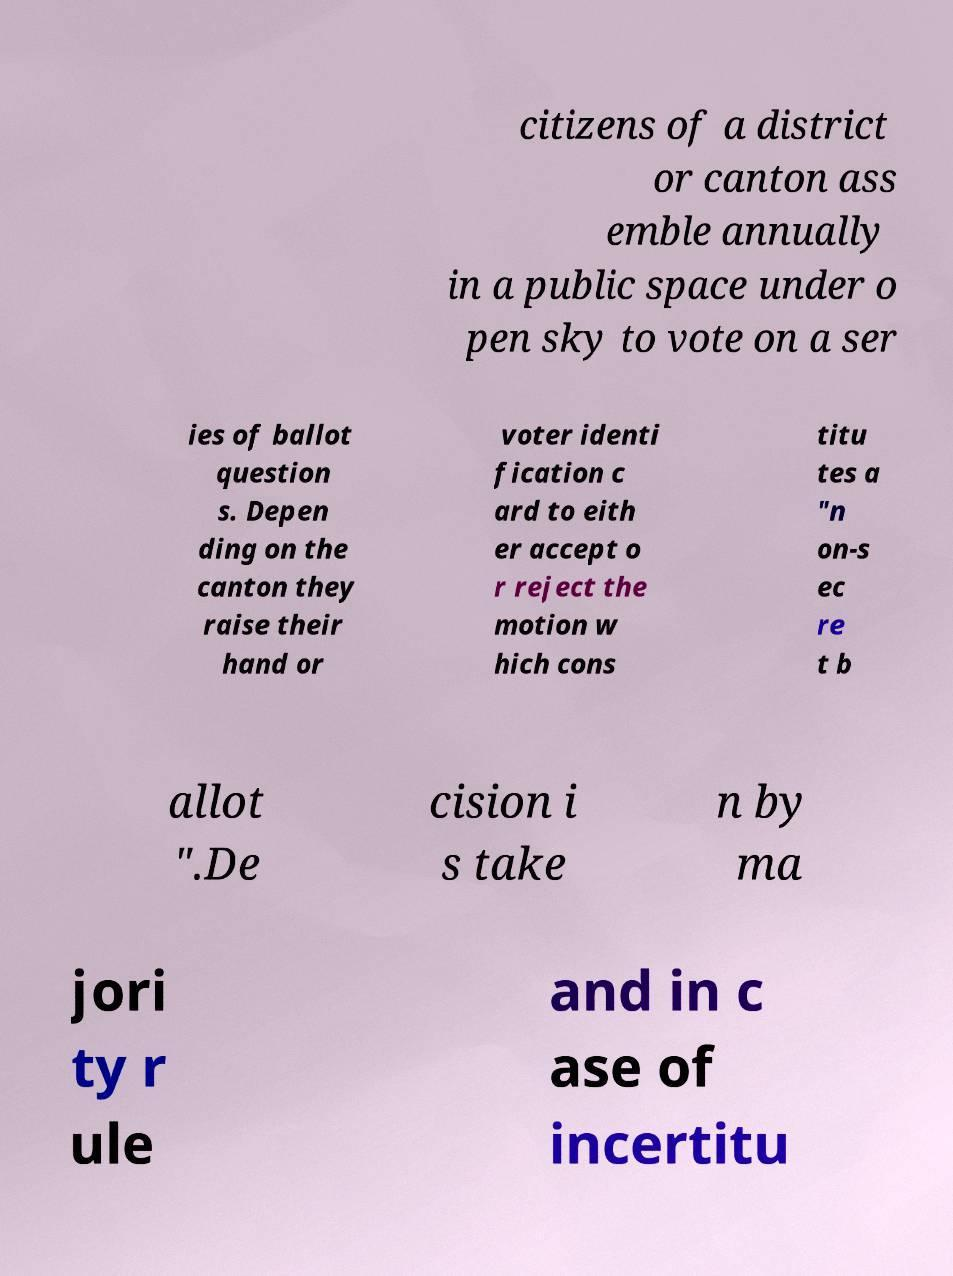Please identify and transcribe the text found in this image. citizens of a district or canton ass emble annually in a public space under o pen sky to vote on a ser ies of ballot question s. Depen ding on the canton they raise their hand or voter identi fication c ard to eith er accept o r reject the motion w hich cons titu tes a "n on-s ec re t b allot ".De cision i s take n by ma jori ty r ule and in c ase of incertitu 